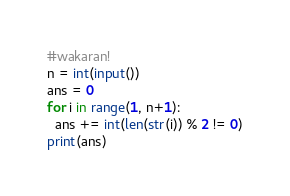Convert code to text. <code><loc_0><loc_0><loc_500><loc_500><_Python_>#wakaran!
n = int(input())
ans = 0
for i in range(1, n+1):
  ans += int(len(str(i)) % 2 != 0)
print(ans)</code> 